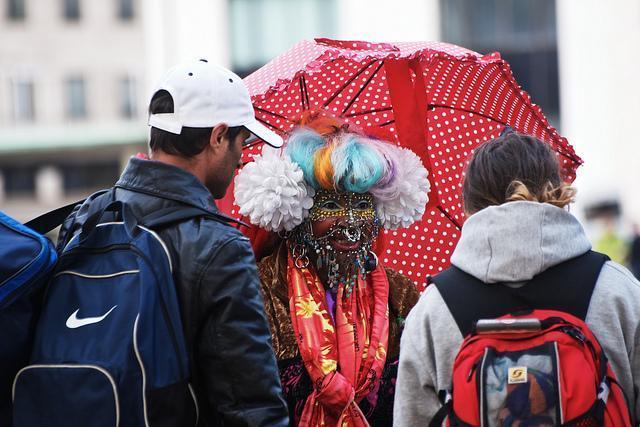How many people are visible?
Give a very brief answer. 3. How many backpacks are there?
Give a very brief answer. 2. 